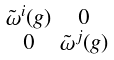Convert formula to latex. <formula><loc_0><loc_0><loc_500><loc_500>\begin{smallmatrix} \tilde { \omega } ^ { i } ( g ) & 0 \\ 0 & \tilde { \omega } ^ { j } ( g ) \end{smallmatrix}</formula> 